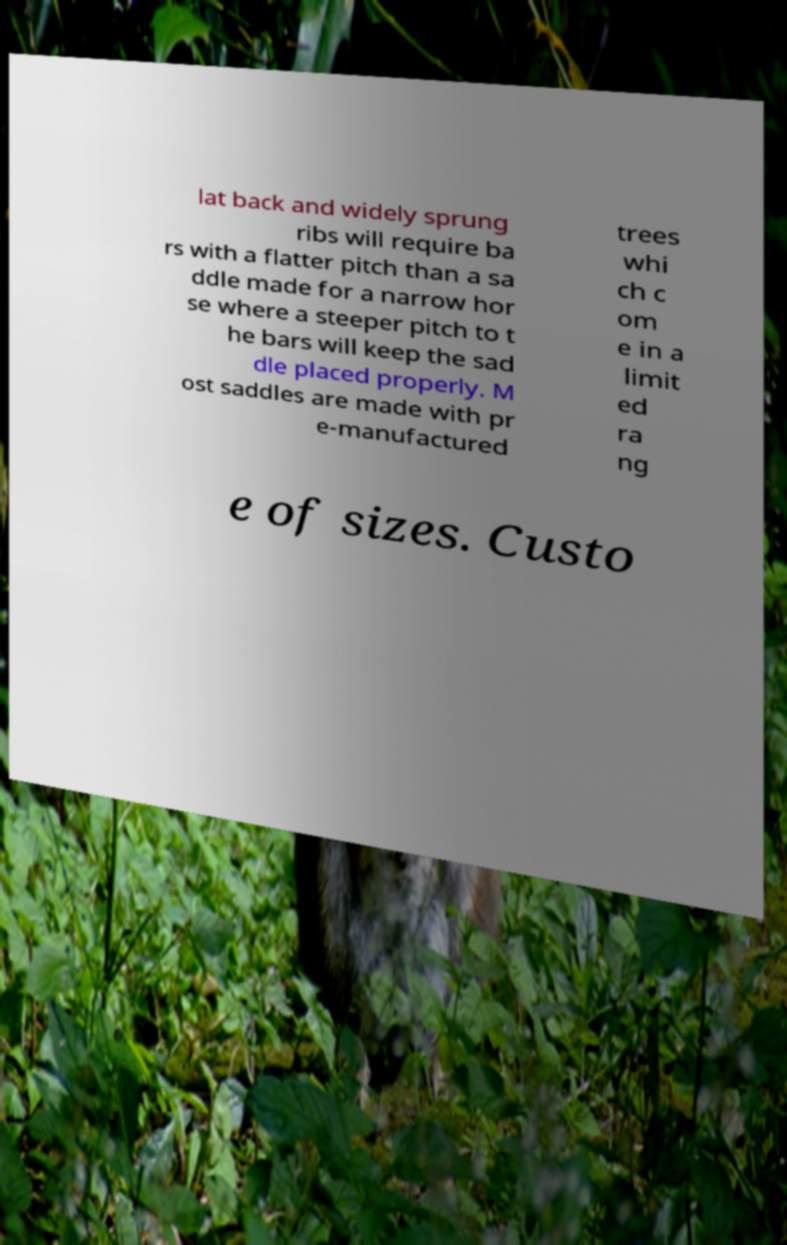Can you accurately transcribe the text from the provided image for me? lat back and widely sprung ribs will require ba rs with a flatter pitch than a sa ddle made for a narrow hor se where a steeper pitch to t he bars will keep the sad dle placed properly. M ost saddles are made with pr e-manufactured trees whi ch c om e in a limit ed ra ng e of sizes. Custo 